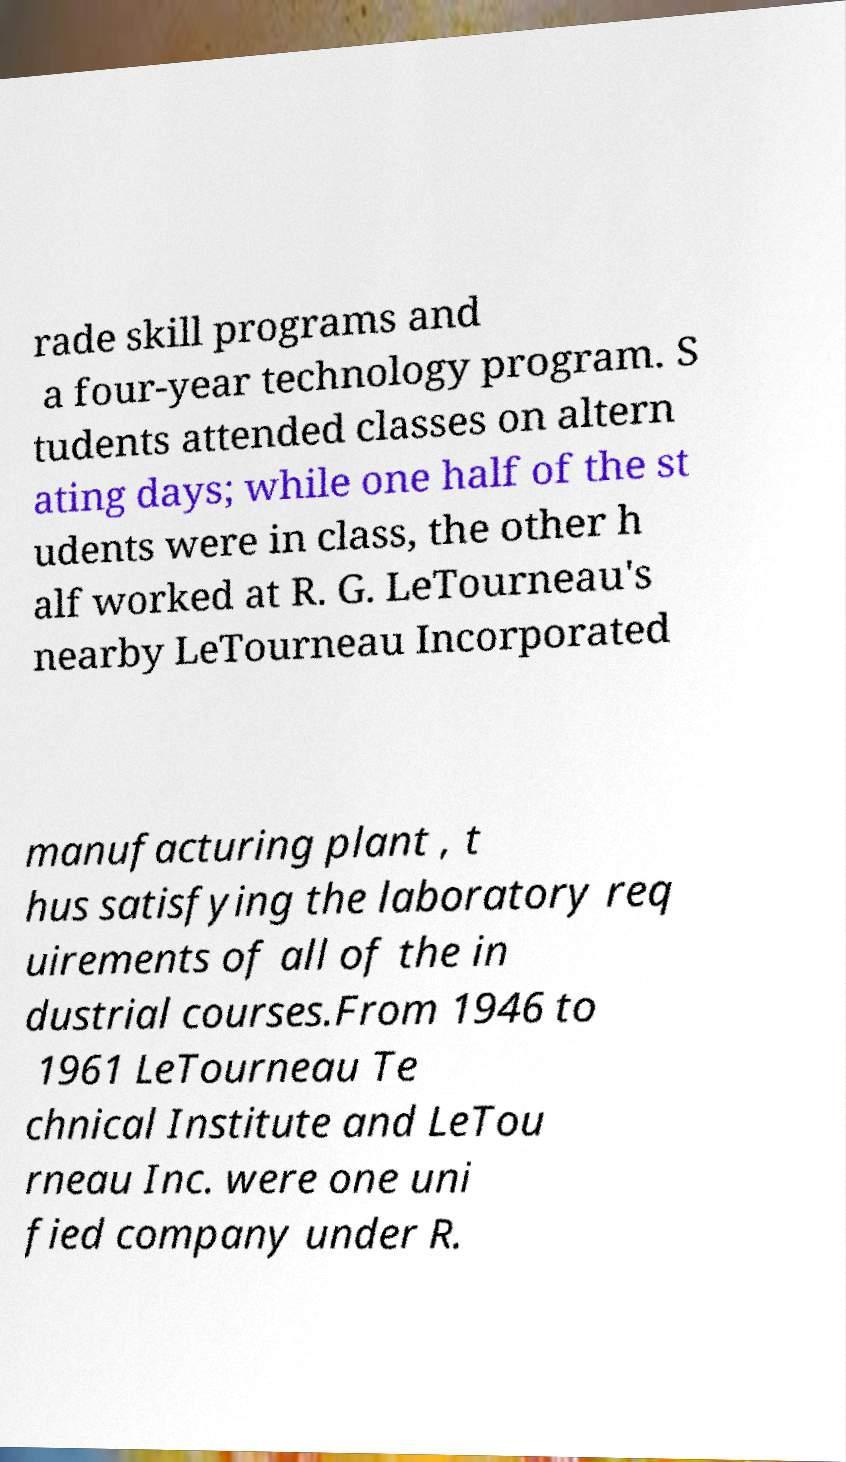For documentation purposes, I need the text within this image transcribed. Could you provide that? rade skill programs and a four-year technology program. S tudents attended classes on altern ating days; while one half of the st udents were in class, the other h alf worked at R. G. LeTourneau's nearby LeTourneau Incorporated manufacturing plant , t hus satisfying the laboratory req uirements of all of the in dustrial courses.From 1946 to 1961 LeTourneau Te chnical Institute and LeTou rneau Inc. were one uni fied company under R. 